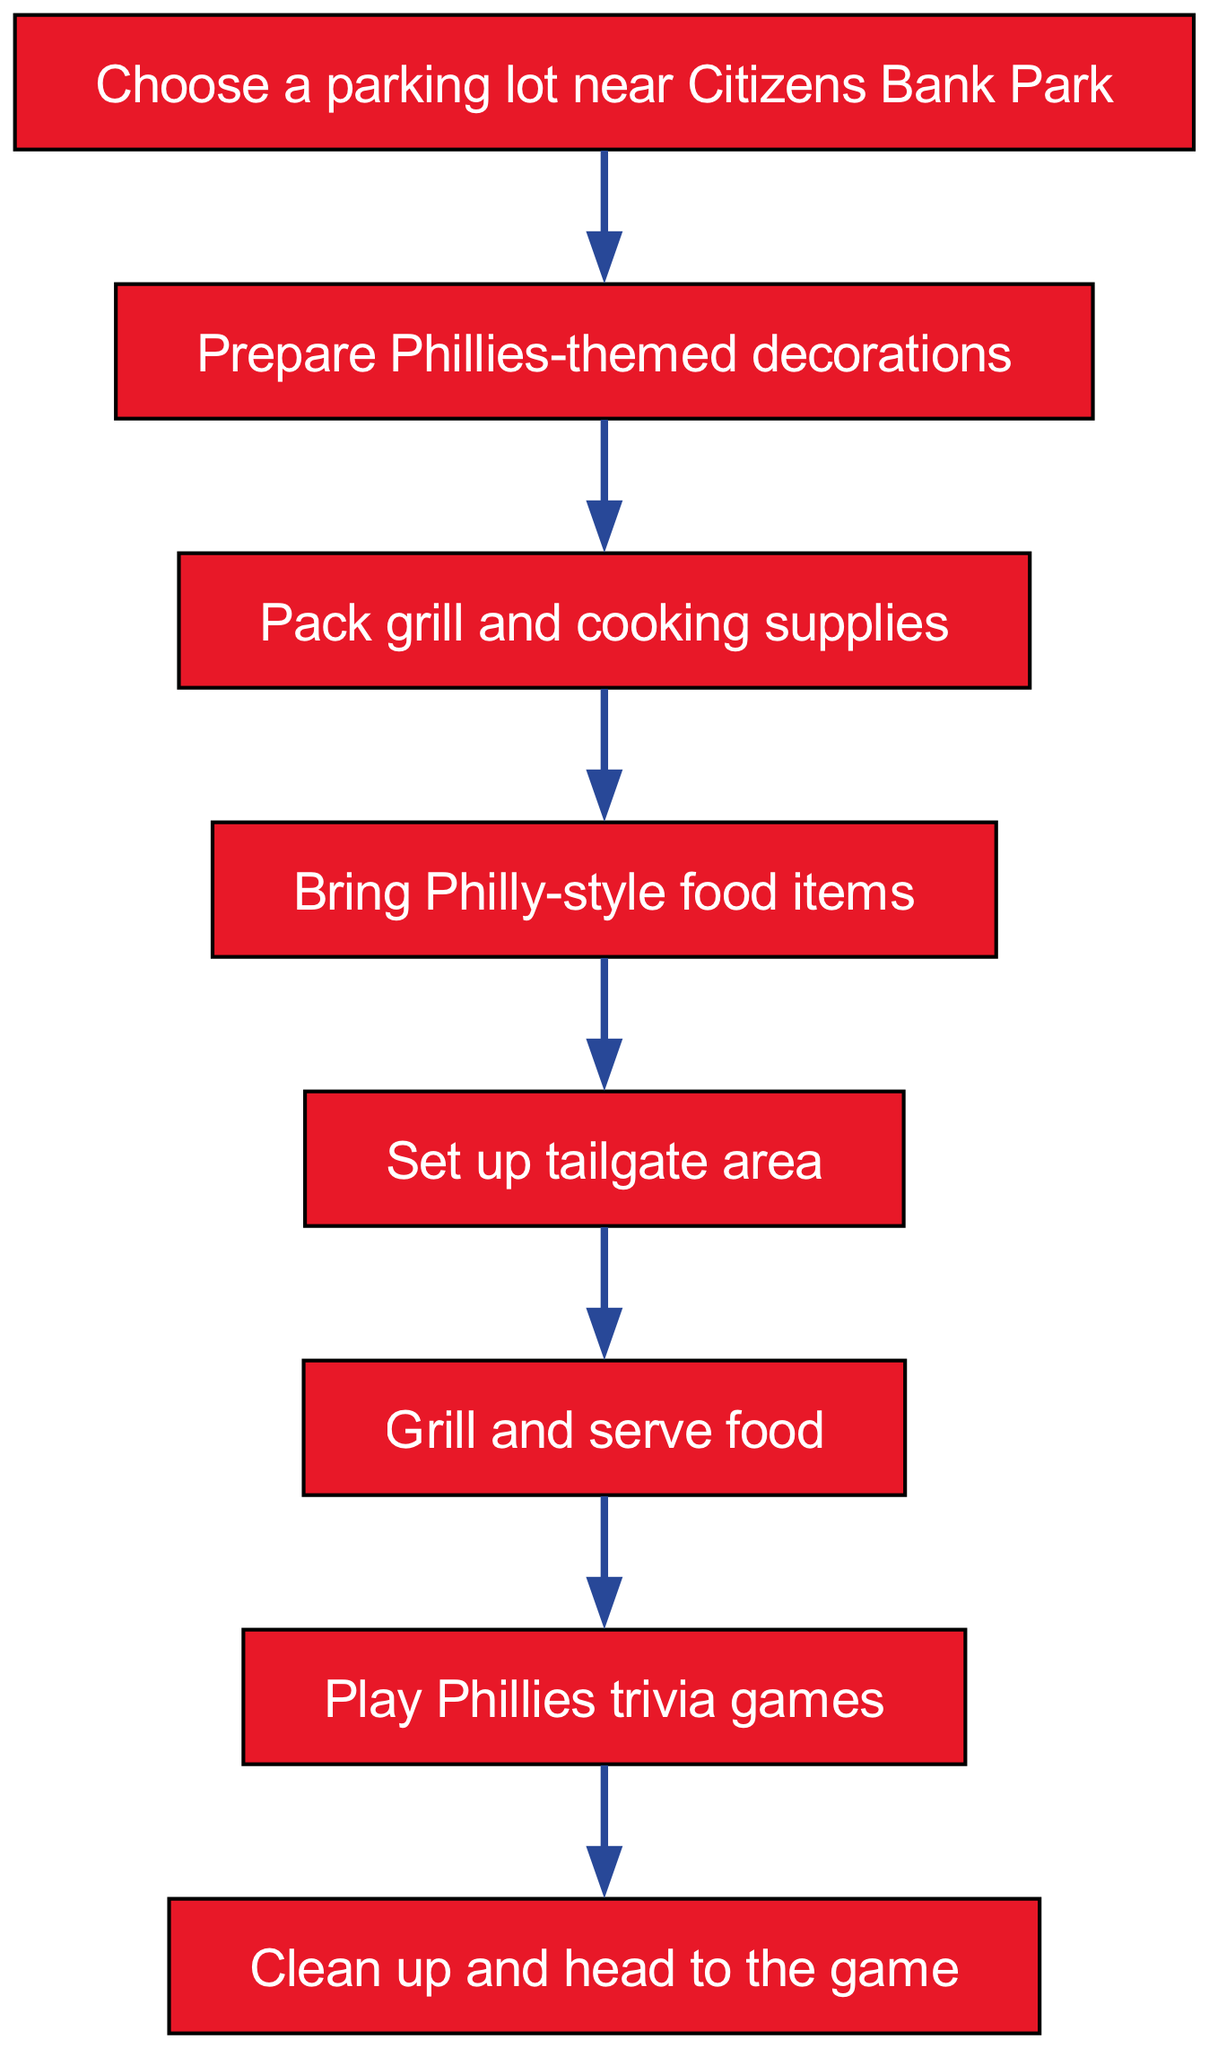What is the first step in the tailgate party organization? The first step listed in the flow chart is to "Choose a parking lot near Citizens Bank Park," which is indicated as the starting node of the process.
Answer: Choose a parking lot near Citizens Bank Park How many nodes are in the diagram? By counting all the unique steps provided in the diagram, there are 8 nodes total in the flow chart.
Answer: 8 What comes after grilling and serving food? Following the step "Grill and serve food," the next step is "Play Phillies trivia games," which is directly connected to the grilling step in the flow chart.
Answer: Play Phillies trivia games What is the last step in the tailgate party process? The final step shown in the diagram is "Clean up and head to the game," which appears after all prior activities have been completed.
Answer: Clean up and head to the game What step follows preparing Phillies-themed decorations? After "Prepare Phillies-themed decorations," the next step is "Pack grill and cooking supplies," indicating the progression of tasks in the flow chart.
Answer: Pack grill and cooking supplies How many edges are connected to the "Set up tailgate area" node? The "Set up tailgate area" node has one edge connecting it to the next step, which is "Grill and serve food," thus highlighting its singular progression in the process.
Answer: 1 What is the relationship between "Bring Philly-style food items" and "Set up tailgate area"? "Bring Philly-style food items" is a prerequisite step that directly precedes "Set up tailgate area," indicating that food preparation must occur before setting up the tailgate.
Answer: Preceding step What is the overall purpose of the flow chart? The flow chart serves as a step-by-step guide to organizing a Phillies-themed tailgate party, outlining all necessary tasks leading up to the game.
Answer: Organizing a Phillies-themed tailgate party 